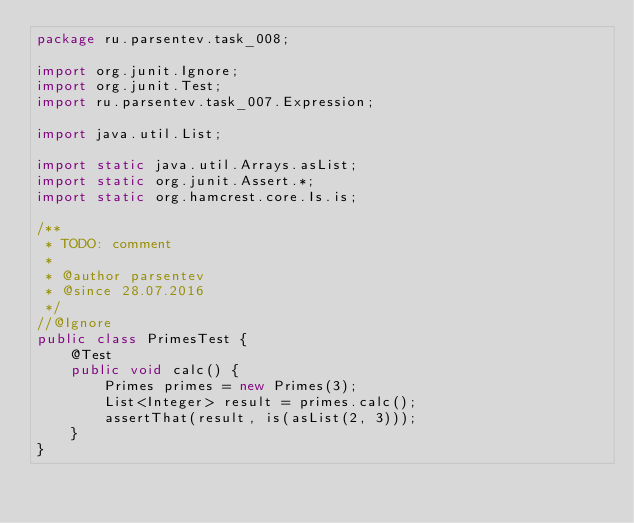Convert code to text. <code><loc_0><loc_0><loc_500><loc_500><_Java_>package ru.parsentev.task_008;

import org.junit.Ignore;
import org.junit.Test;
import ru.parsentev.task_007.Expression;

import java.util.List;

import static java.util.Arrays.asList;
import static org.junit.Assert.*;
import static org.hamcrest.core.Is.is;

/**
 * TODO: comment
 *
 * @author parsentev
 * @since 28.07.2016
 */
//@Ignore
public class PrimesTest {
    @Test
    public void calc() {
        Primes primes = new Primes(3);
        List<Integer> result = primes.calc();
        assertThat(result, is(asList(2, 3)));
    }
}
</code> 